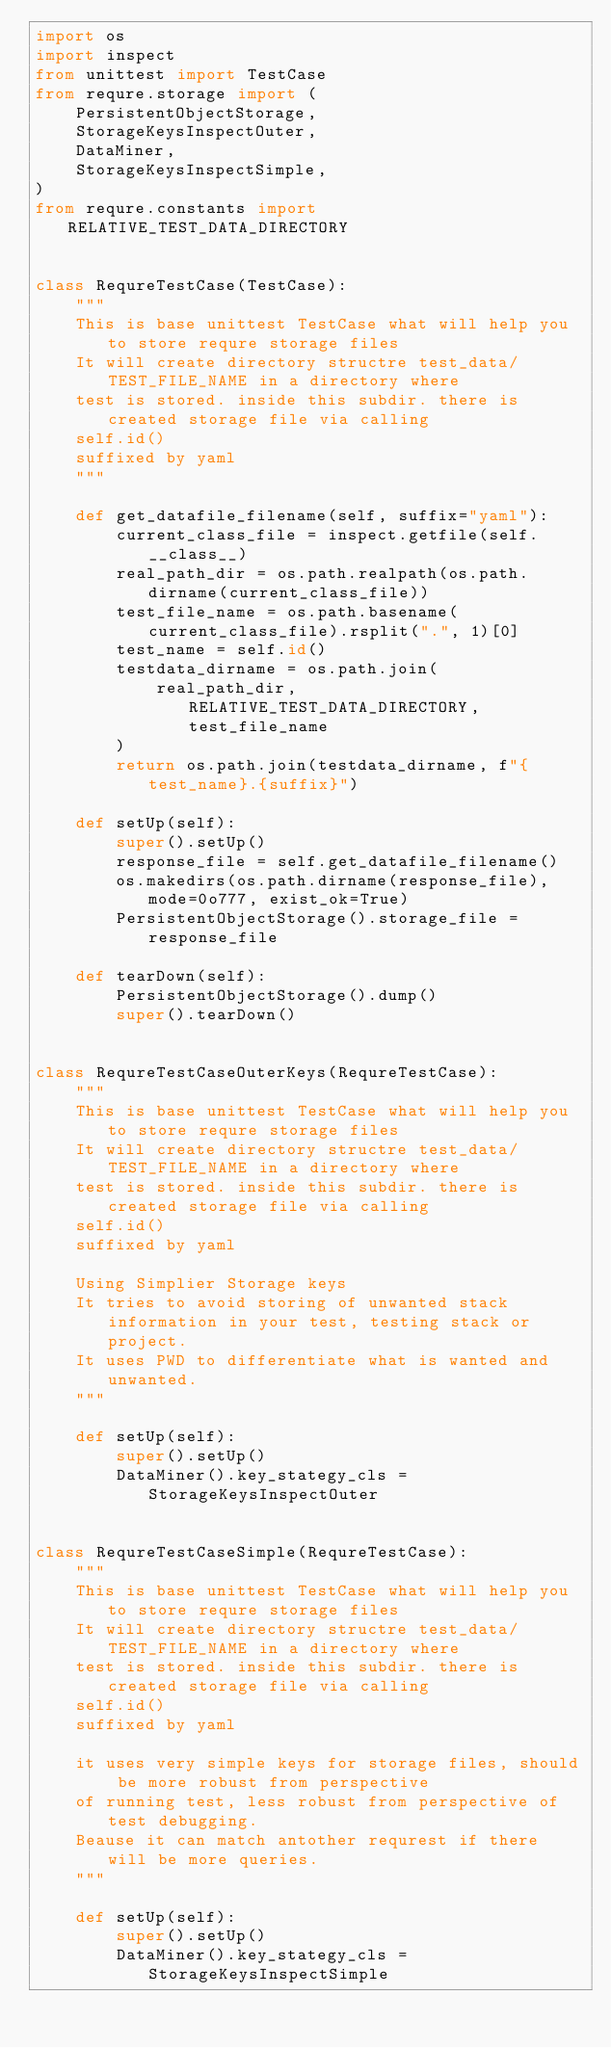Convert code to text. <code><loc_0><loc_0><loc_500><loc_500><_Python_>import os
import inspect
from unittest import TestCase
from requre.storage import (
    PersistentObjectStorage,
    StorageKeysInspectOuter,
    DataMiner,
    StorageKeysInspectSimple,
)
from requre.constants import RELATIVE_TEST_DATA_DIRECTORY


class RequreTestCase(TestCase):
    """
    This is base unittest TestCase what will help you to store requre storage files
    It will create directory structre test_data/TEST_FILE_NAME in a directory where
    test is stored. inside this subdir. there is created storage file via calling
    self.id()
    suffixed by yaml
    """

    def get_datafile_filename(self, suffix="yaml"):
        current_class_file = inspect.getfile(self.__class__)
        real_path_dir = os.path.realpath(os.path.dirname(current_class_file))
        test_file_name = os.path.basename(current_class_file).rsplit(".", 1)[0]
        test_name = self.id()
        testdata_dirname = os.path.join(
            real_path_dir, RELATIVE_TEST_DATA_DIRECTORY, test_file_name
        )
        return os.path.join(testdata_dirname, f"{test_name}.{suffix}")

    def setUp(self):
        super().setUp()
        response_file = self.get_datafile_filename()
        os.makedirs(os.path.dirname(response_file), mode=0o777, exist_ok=True)
        PersistentObjectStorage().storage_file = response_file

    def tearDown(self):
        PersistentObjectStorage().dump()
        super().tearDown()


class RequreTestCaseOuterKeys(RequreTestCase):
    """
    This is base unittest TestCase what will help you to store requre storage files
    It will create directory structre test_data/TEST_FILE_NAME in a directory where
    test is stored. inside this subdir. there is created storage file via calling
    self.id()
    suffixed by yaml

    Using Simplier Storage keys
    It tries to avoid storing of unwanted stack information in your test, testing stack or project.
    It uses PWD to differentiate what is wanted and unwanted.
    """

    def setUp(self):
        super().setUp()
        DataMiner().key_stategy_cls = StorageKeysInspectOuter


class RequreTestCaseSimple(RequreTestCase):
    """
    This is base unittest TestCase what will help you to store requre storage files
    It will create directory structre test_data/TEST_FILE_NAME in a directory where
    test is stored. inside this subdir. there is created storage file via calling
    self.id()
    suffixed by yaml

    it uses very simple keys for storage files, should be more robust from perspective
    of running test, less robust from perspective of test debugging.
    Beause it can match antother requrest if there will be more queries.
    """

    def setUp(self):
        super().setUp()
        DataMiner().key_stategy_cls = StorageKeysInspectSimple
</code> 